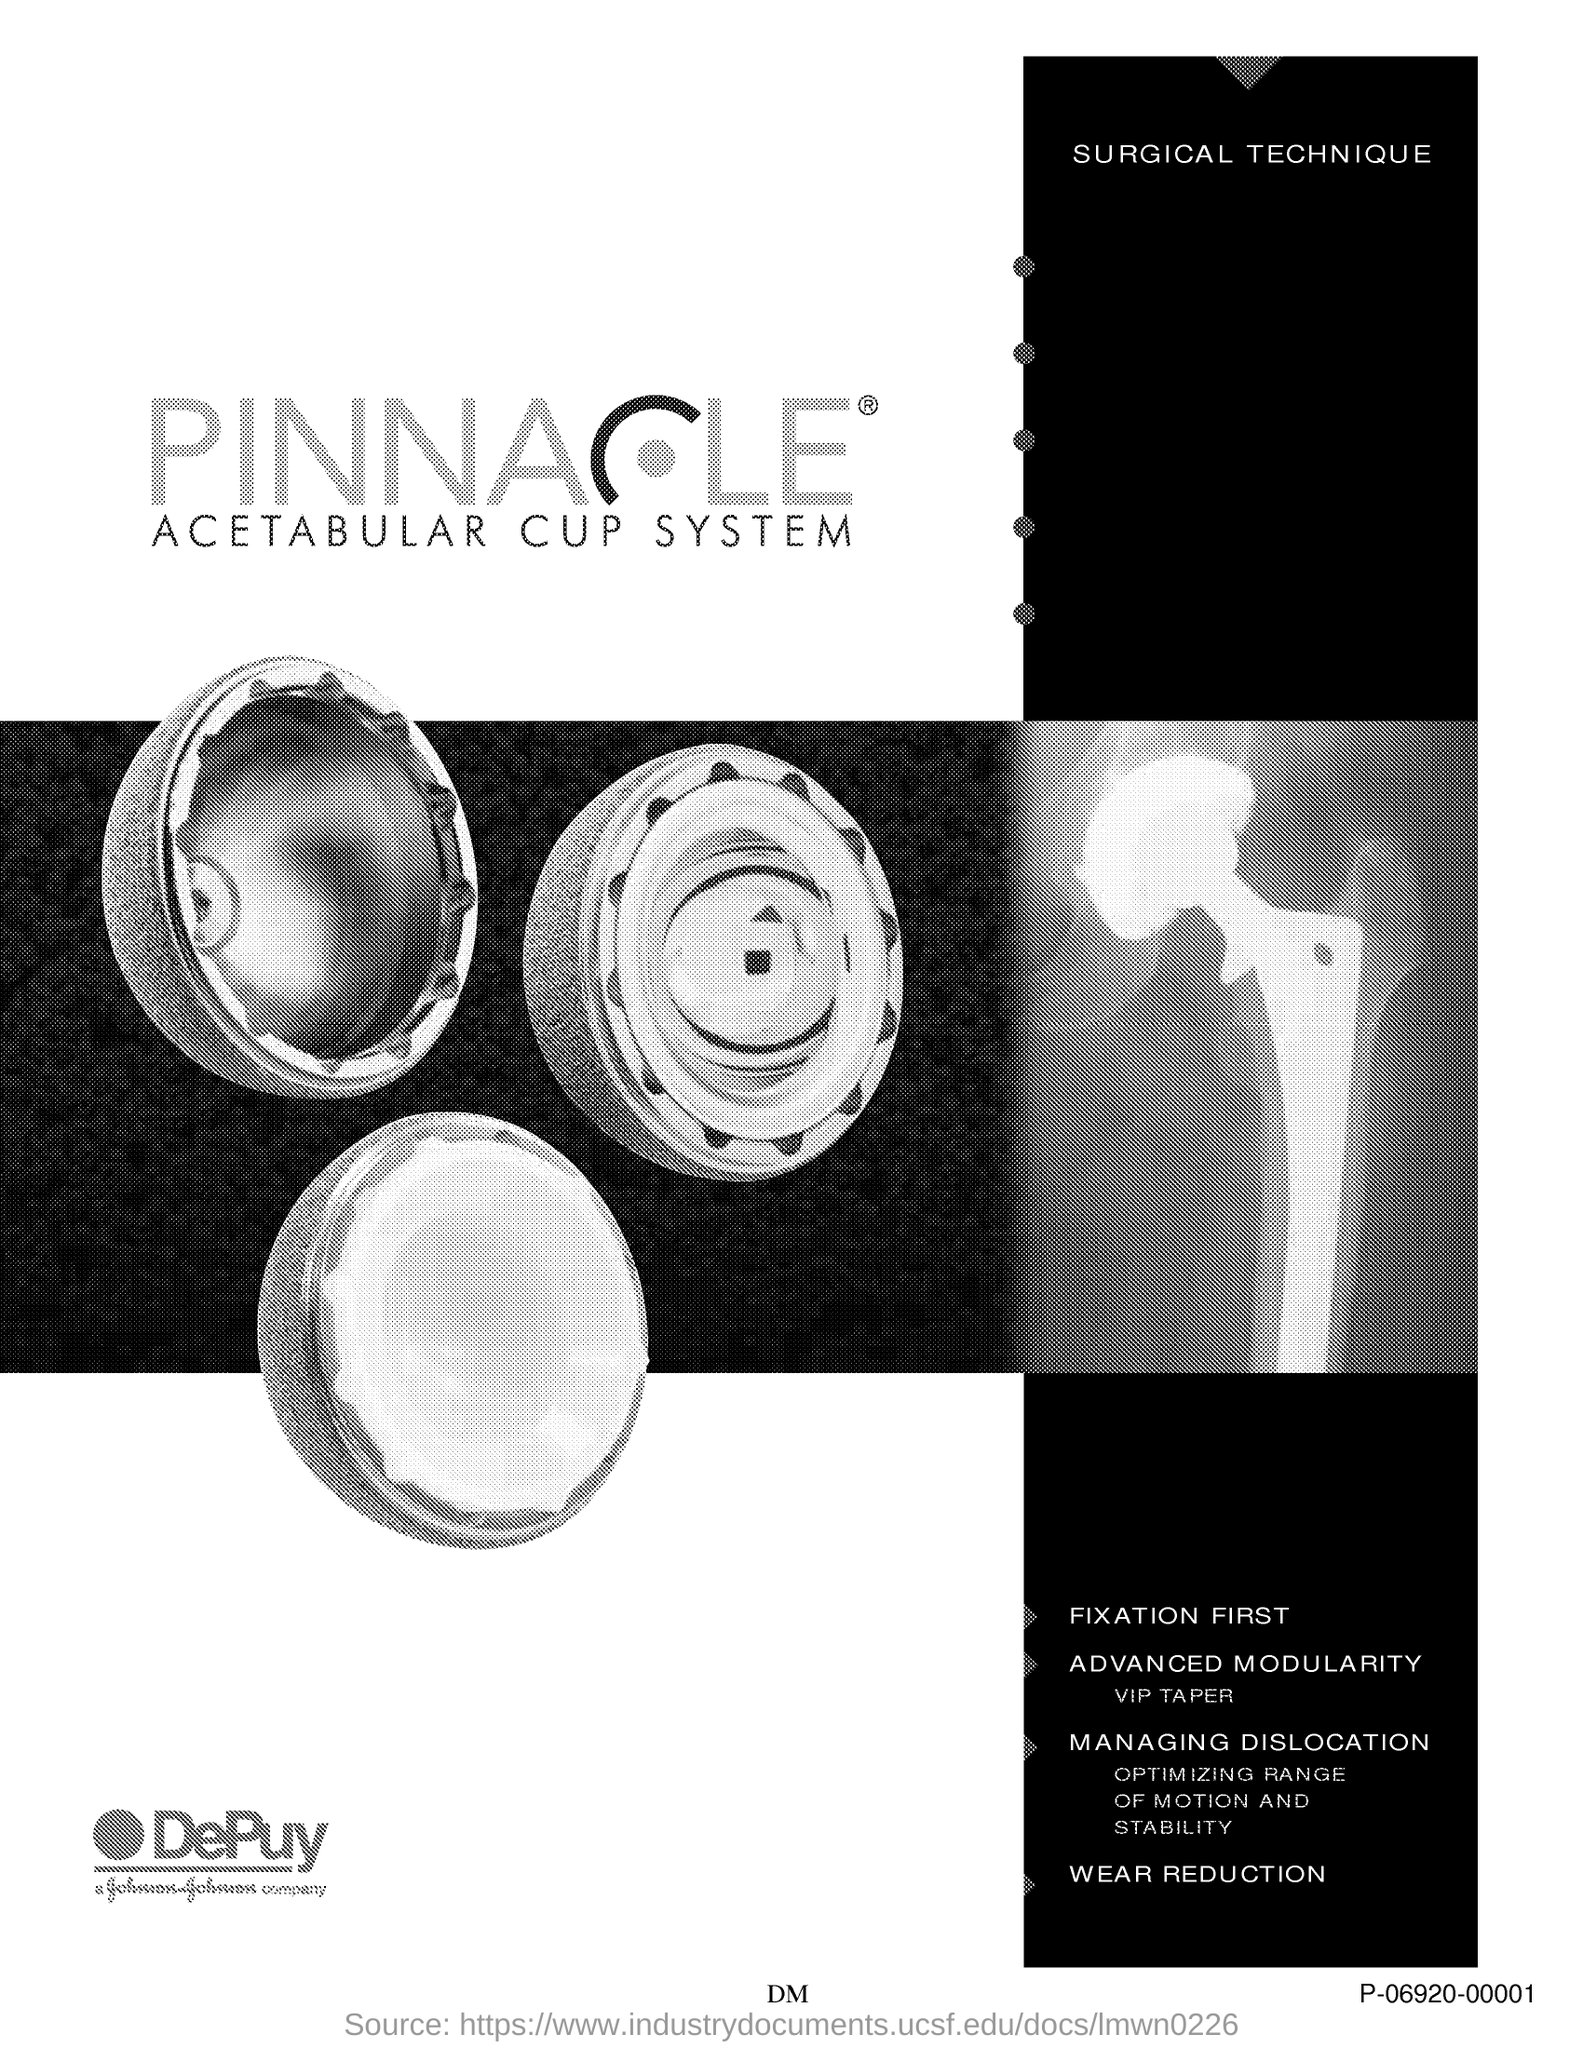What is the technique mentioned in the document?
Keep it short and to the point. SURGICAL TECHNIQUE. 